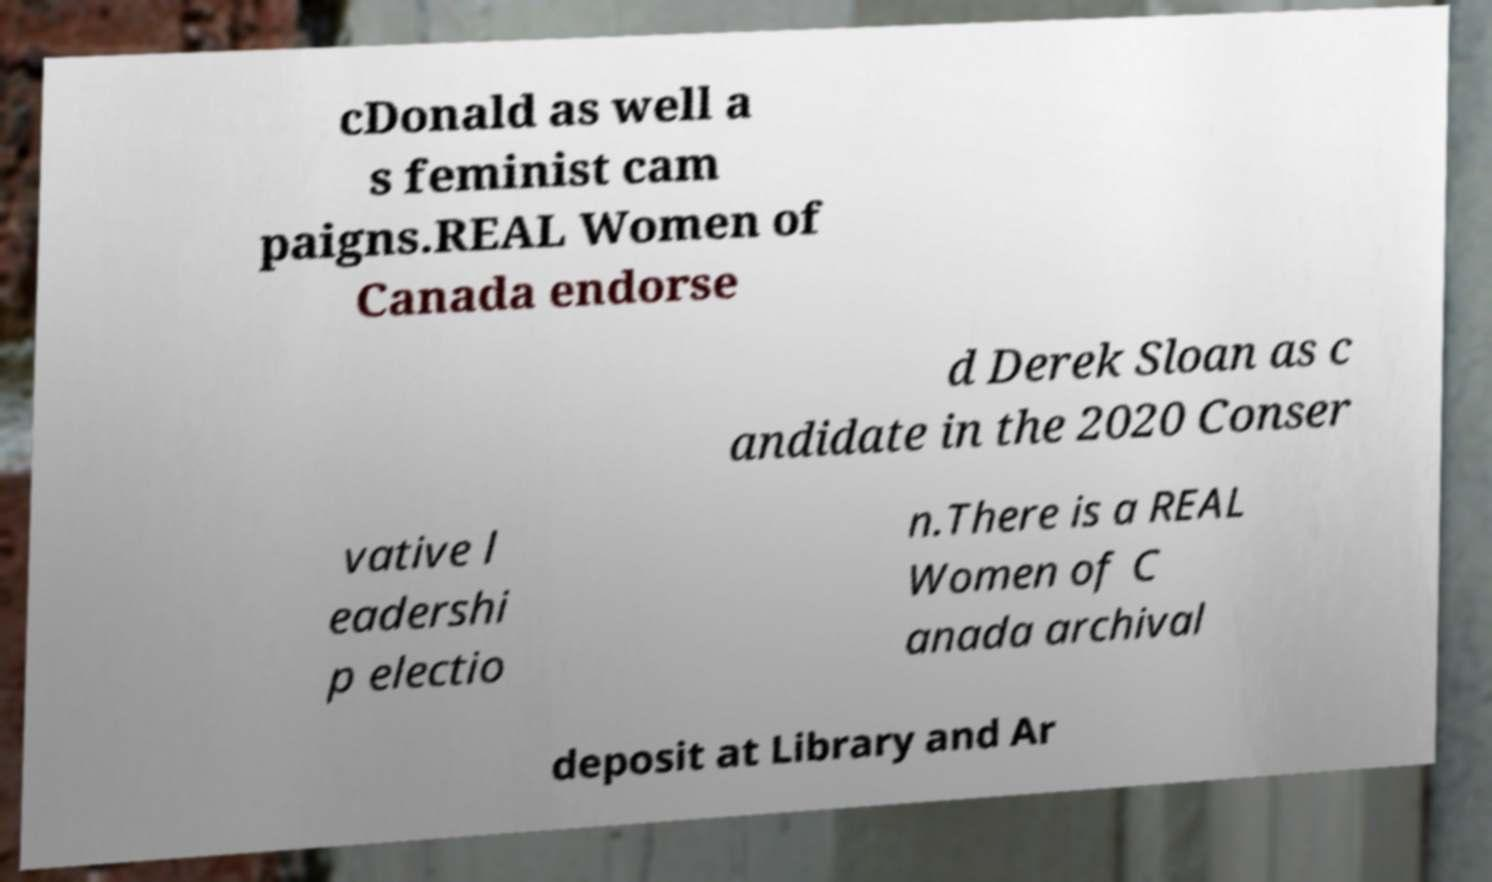There's text embedded in this image that I need extracted. Can you transcribe it verbatim? cDonald as well a s feminist cam paigns.REAL Women of Canada endorse d Derek Sloan as c andidate in the 2020 Conser vative l eadershi p electio n.There is a REAL Women of C anada archival deposit at Library and Ar 